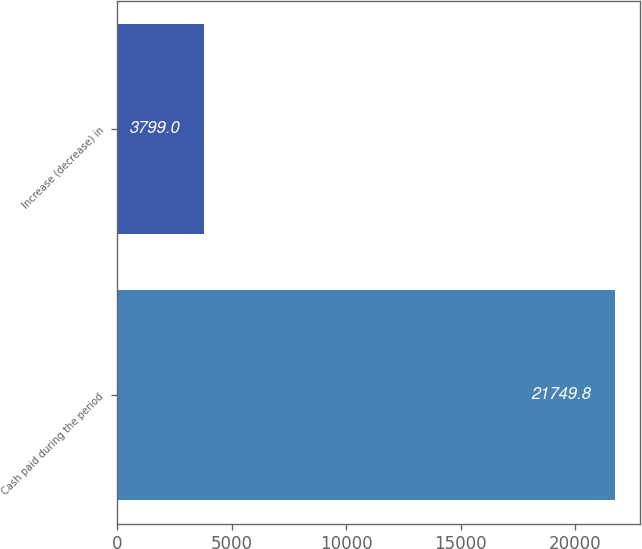Convert chart to OTSL. <chart><loc_0><loc_0><loc_500><loc_500><bar_chart><fcel>Cash paid during the period<fcel>Increase (decrease) in<nl><fcel>21749.8<fcel>3799<nl></chart> 